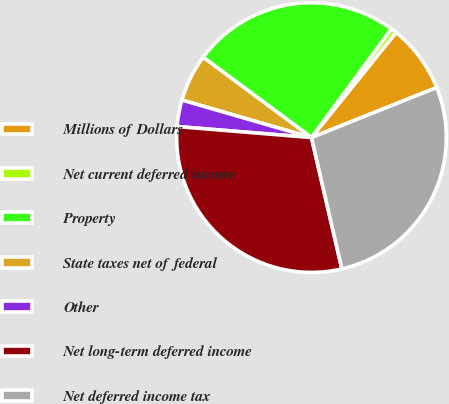Convert chart. <chart><loc_0><loc_0><loc_500><loc_500><pie_chart><fcel>Millions of Dollars<fcel>Net current deferred income<fcel>Property<fcel>State taxes net of federal<fcel>Other<fcel>Net long-term deferred income<fcel>Net deferred income tax<nl><fcel>8.17%<fcel>0.69%<fcel>24.94%<fcel>5.67%<fcel>3.18%<fcel>29.92%<fcel>27.43%<nl></chart> 